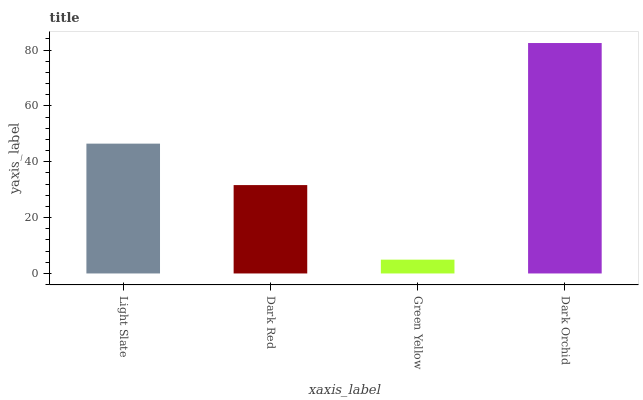Is Green Yellow the minimum?
Answer yes or no. Yes. Is Dark Orchid the maximum?
Answer yes or no. Yes. Is Dark Red the minimum?
Answer yes or no. No. Is Dark Red the maximum?
Answer yes or no. No. Is Light Slate greater than Dark Red?
Answer yes or no. Yes. Is Dark Red less than Light Slate?
Answer yes or no. Yes. Is Dark Red greater than Light Slate?
Answer yes or no. No. Is Light Slate less than Dark Red?
Answer yes or no. No. Is Light Slate the high median?
Answer yes or no. Yes. Is Dark Red the low median?
Answer yes or no. Yes. Is Green Yellow the high median?
Answer yes or no. No. Is Dark Orchid the low median?
Answer yes or no. No. 